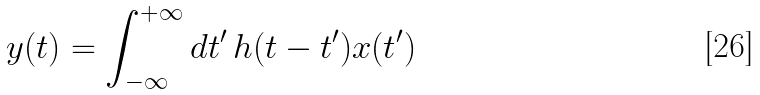Convert formula to latex. <formula><loc_0><loc_0><loc_500><loc_500>y ( t ) = \int _ { - \infty } ^ { + \infty } d t ^ { \prime } \, h ( t - t ^ { \prime } ) x ( t ^ { \prime } )</formula> 